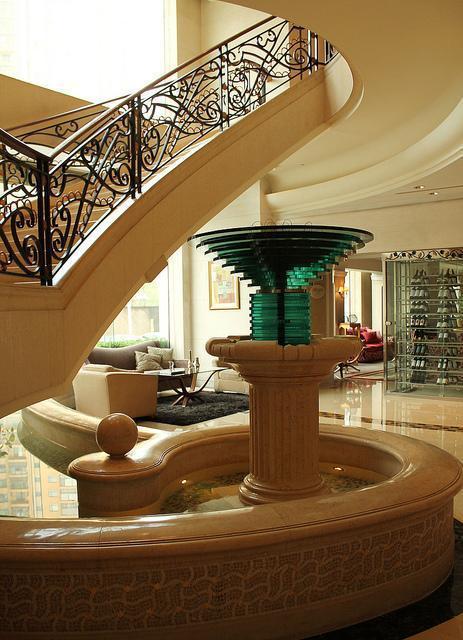How many couches can you see?
Give a very brief answer. 2. 